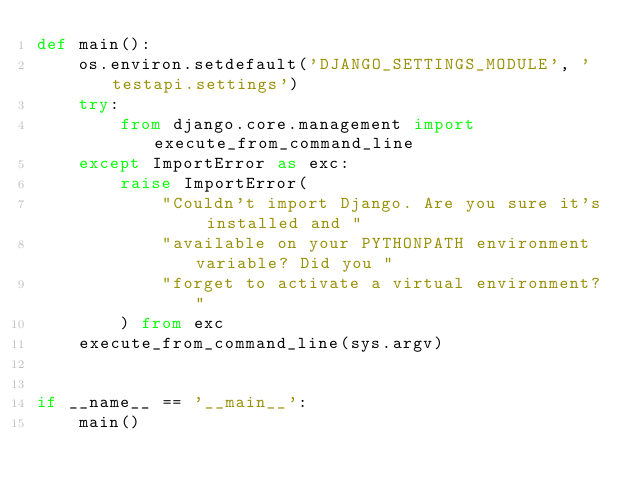<code> <loc_0><loc_0><loc_500><loc_500><_Python_>def main():
    os.environ.setdefault('DJANGO_SETTINGS_MODULE', 'testapi.settings')
    try:
        from django.core.management import execute_from_command_line
    except ImportError as exc:
        raise ImportError(
            "Couldn't import Django. Are you sure it's installed and "
            "available on your PYTHONPATH environment variable? Did you "
            "forget to activate a virtual environment?"
        ) from exc
    execute_from_command_line(sys.argv)


if __name__ == '__main__':
    main()
</code> 